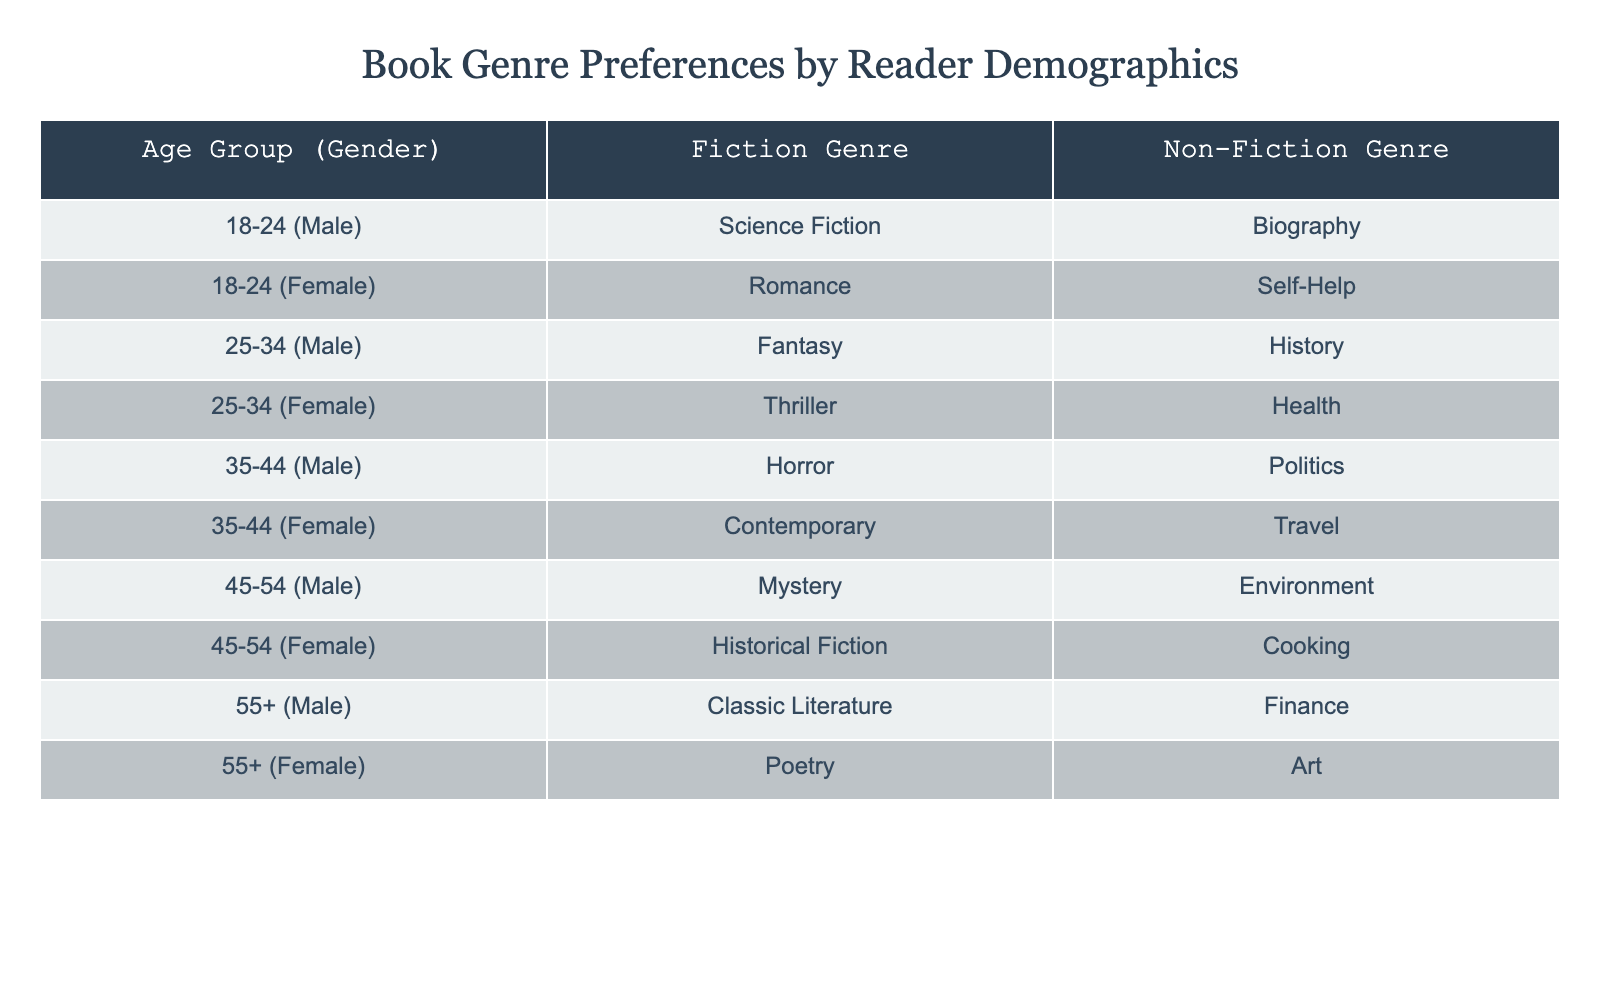What is the most popular fiction genre among males aged 25-34? In the table, the entry for males in the 25-34 age group shows that their preferred fiction genre is Fantasy.
Answer: Fantasy How many females prefer Historical Fiction as a genre? The table lists one entry for females in the 45-54 age group with Historical Fiction as their preferred genre.
Answer: 1 Is there a preference for Biography among males? Yes, there is one entry for males that states their preference for Biography as their non-fiction genre.
Answer: Yes What is the difference between the number of males preferring Science Fiction and the number preferring Mystery? There is one male in the 18-24 age group that prefers Science Fiction and one male in the 45-54 age group that prefers Mystery. The difference is 1 - 1 = 0.
Answer: 0 How many total entries are listed for females in the age group 35-44? The table shows one entry for females aged 35-44 (Contemporary as Fiction Genre), so the total is 1.
Answer: 1 Do more males prefer Fiction over Non-Fiction? To find this, we count the males who have a Fiction genre preference (5 entries found) compared to Non-Fiction (5 entries found). Since they are equal, the answer is no.
Answer: No Which is the most common Non-Fiction genre among females? By examining the table, females prefer Self-Help, Health, Travel, Cooking, and Art. Since these are unique entries, there is no single most common genre, as each has only one entry.
Answer: None In the age group 55+, what is the preference for Fiction genre among females? In the table, the entry for females aged 55+ states that their preferred fiction genre is Poetry.
Answer: Poetry What percentage of males prefer Horror as their Fiction genre in comparison to other genres? There is 1 male preferring Horror out of 5 males in total, so the percentage is (1/5)*100 = 20%.
Answer: 20% 